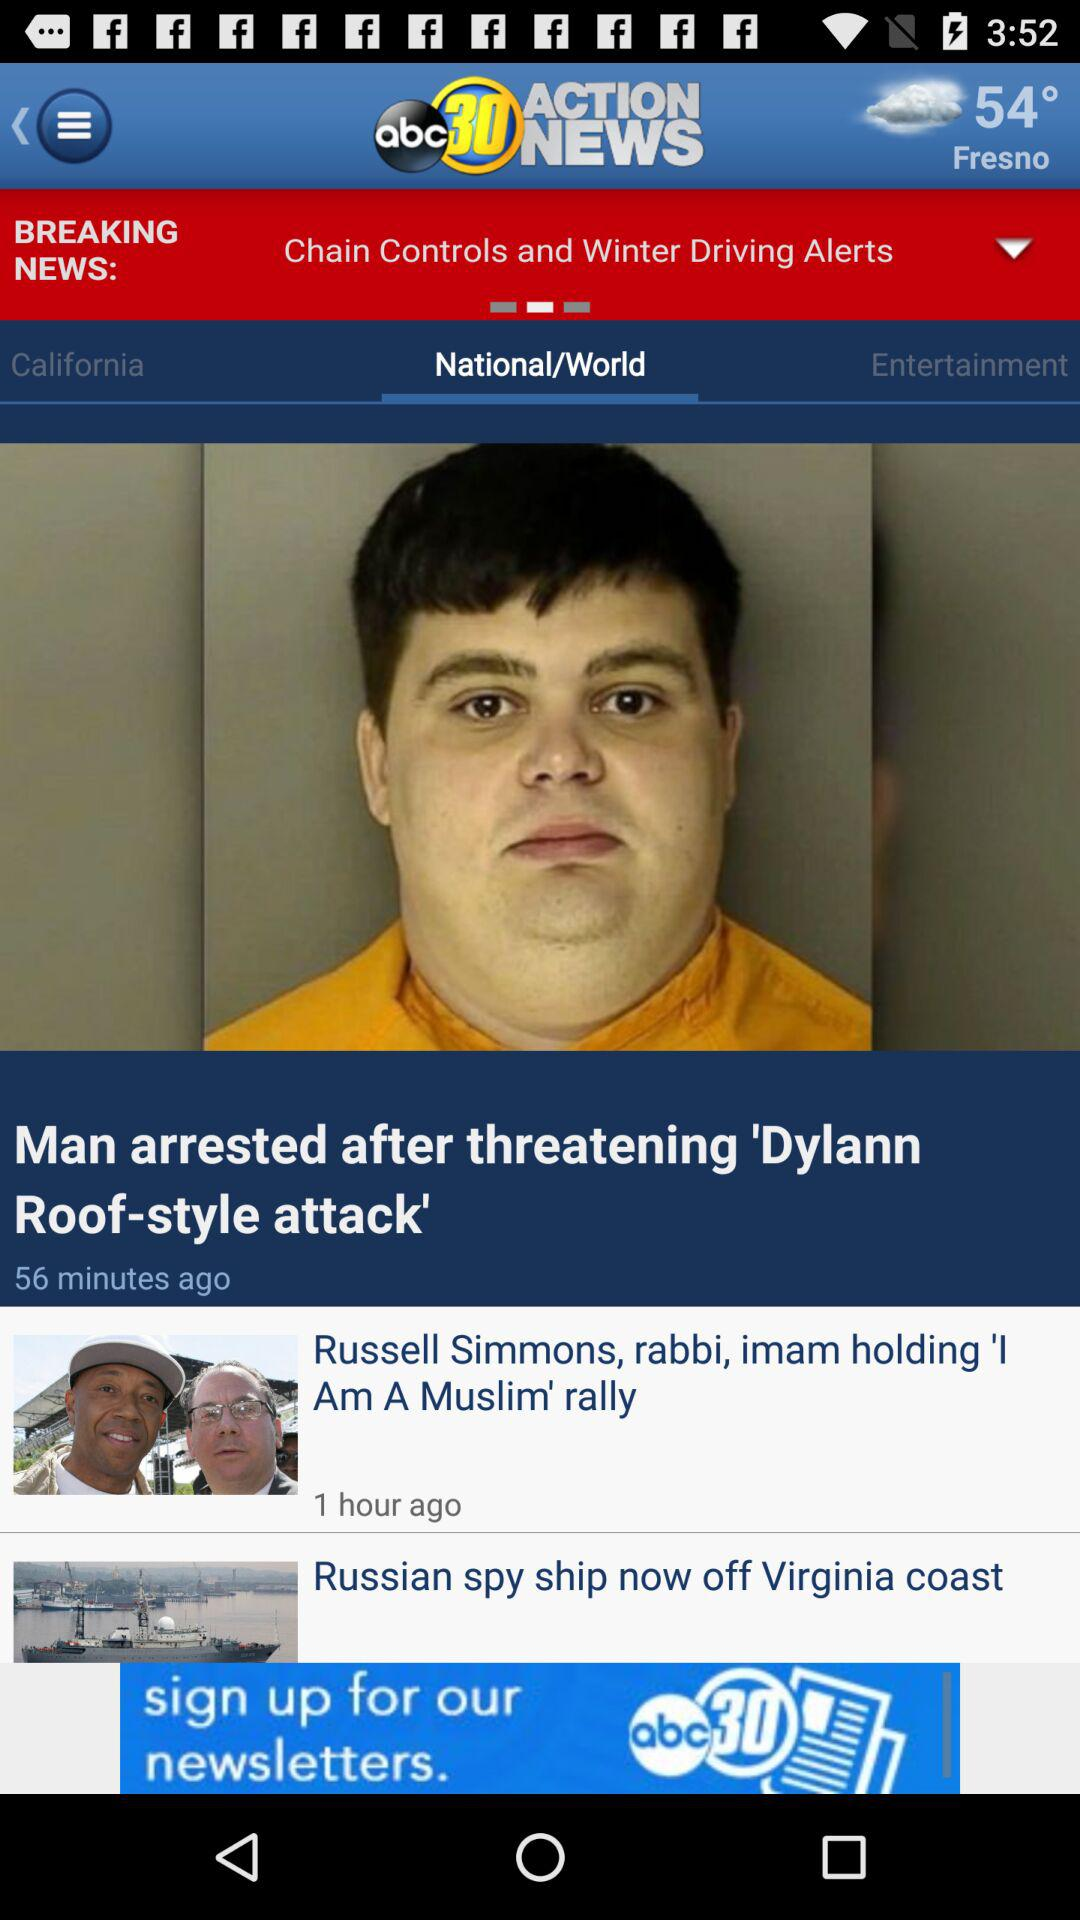When was the news about "Man arrested after threatening 'Dylann Roof-style attack'" published? The news about "Man arrested after threatening 'Dylan Roof-style attack'" was published 56 minutes ago. 